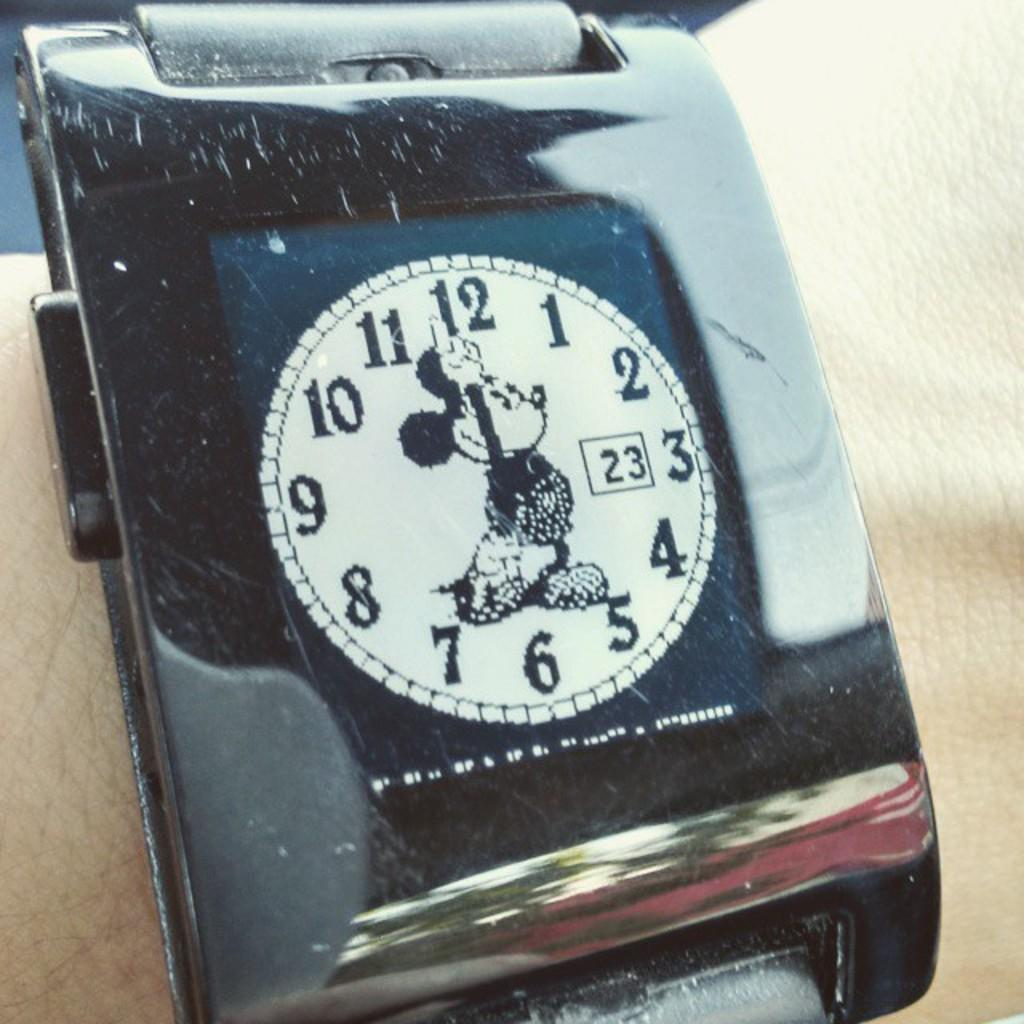<image>
Present a compact description of the photo's key features. A Mickey Mouse watch which has the number 23 on it. 